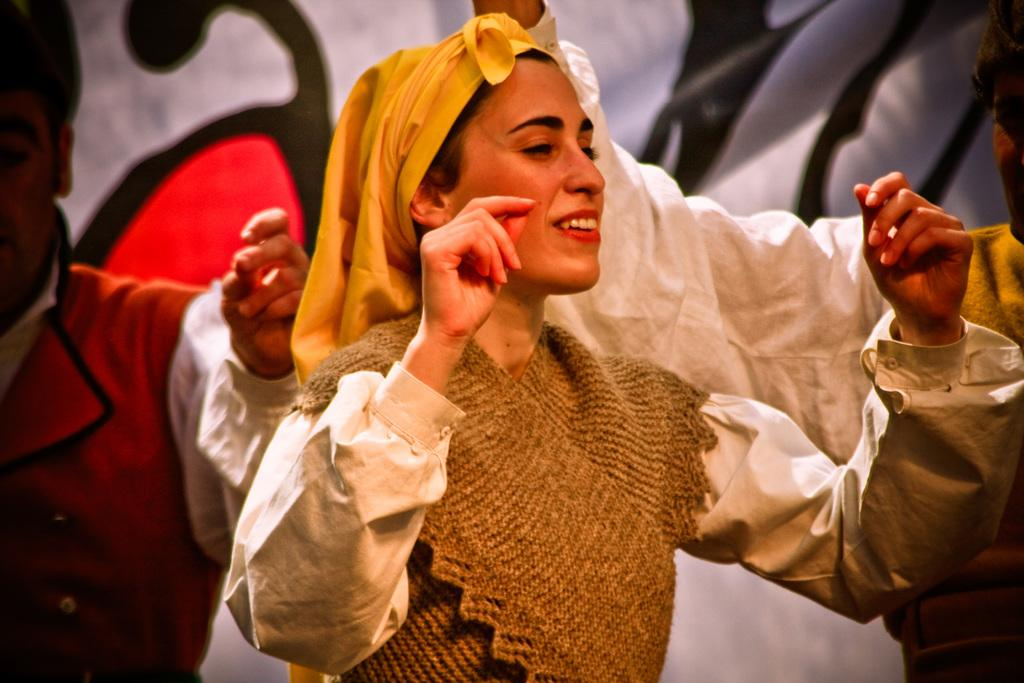Who is the main subject in the image? There is a woman in the center of the image. Are there any other people visible in the image? Yes, there are people visible on the backside of the image. What else can be seen in the image besides the people? There is a banner in the image. What type of eggnog is being served at the event depicted in the image? There is no mention of eggnog or any event in the image; it simply shows a woman and people in the background with a banner. 